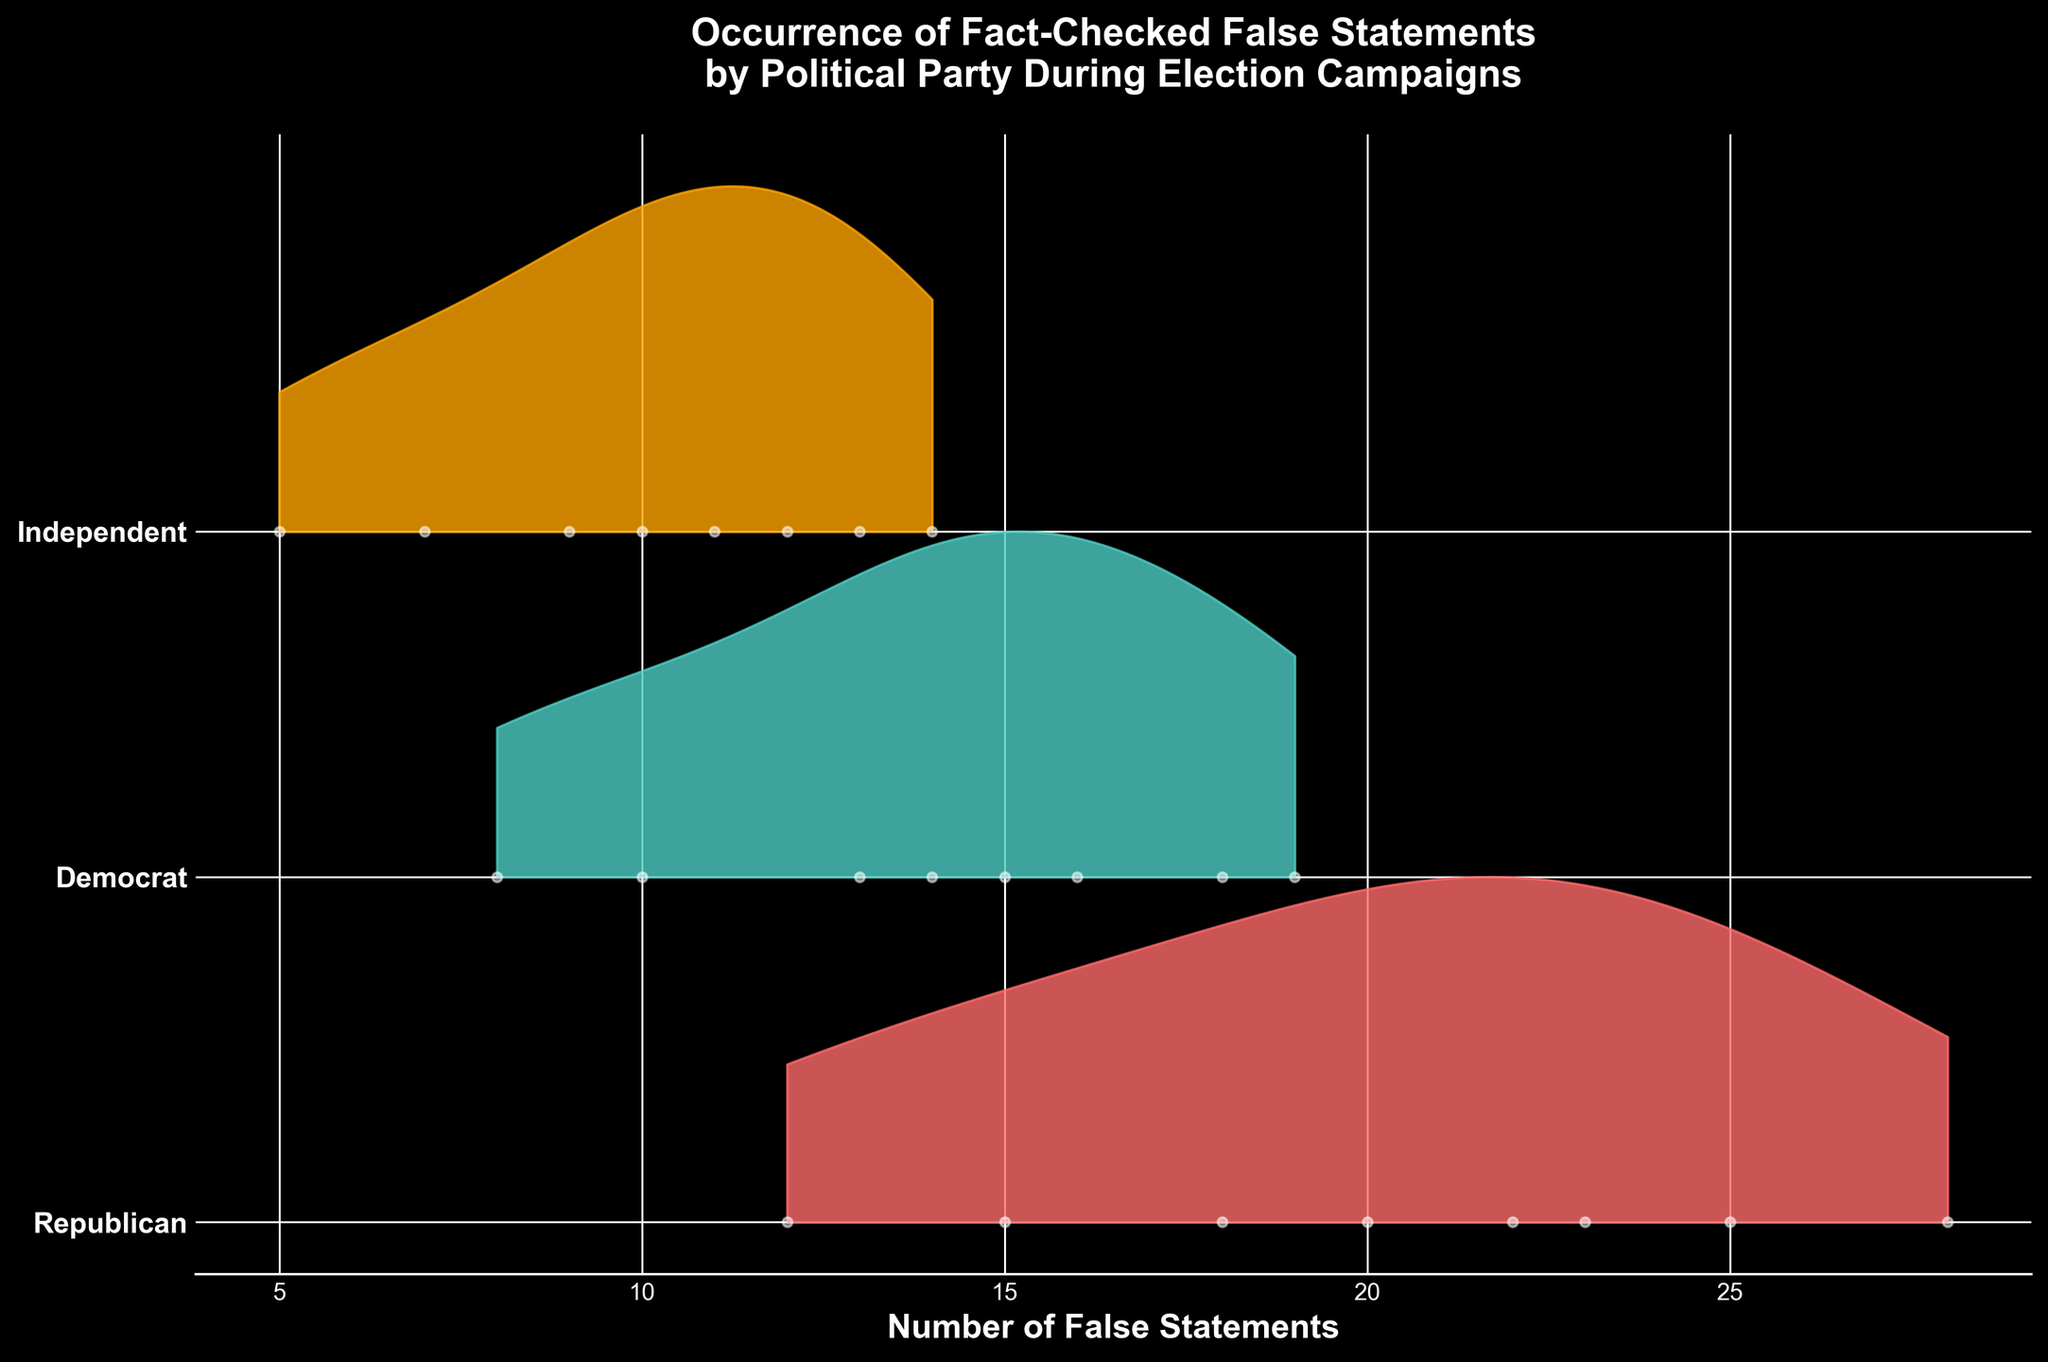What's the title of the figure? The title is positioned at the top of the figure, and it should be clearly visible. It provides a description of what the figure is about.
Answer: Occurrence of Fact-Checked False Statements by Political Party During Election Campaigns What does the x-axis represent? The x-axis label is typically found at the bottom, and it indicates what the horizontal axis measures.
Answer: Number of False Statements Which political party has the highest peak in the number of false statements? By looking at the peaks of the ridgelines for each political party, we can determine which party reached the highest number of false statements. The peak of each ridgeline shows the highest kernel density estimate.
Answer: Republican What color is used to represent the Independent party? The color of each ridgeline indicates different political parties. By identifying the color of the ridgeline corresponding to the Independent party, we can answer this question.
Answer: Orange What is the range of false statements for the Democrat party? The range of false statements can be determined by looking at the spread of the Democrats' ridgeline, which displays the minimum and maximum values reached by this party.
Answer: 8 to 19 What's the average maximum number of false statements made by the three parties? To find this, identify the maximum number of false statements for each of the three parties, sum these maximum values, and then divide by the number of parties (3). Republican: 28, Democrat: 19, Independent: 14. (28 + 19 + 14) / 3
Answer: 20.33 Which party shows the most variability in the number of false statements? Variability can be judged by looking at the width and spread of each ridgeline. The party with the broadest ridgeline and the most spread out points shows the most variability.
Answer: Republican During Week 5, how do the false statements made by Republicans compare to those made by Democrats and Independents? Locate the points for Week 5 on the plot and compare the positions of false statements for each party. Republicans have 25 false statements, Democrats 18, and Independents 13.
Answer: Republicans > Democrats > Independents Which weeks show a consistent increase in false statements for all parties? To identify weeks with an increasing trend for all parties, examine the plot for sequential points where the false statements for all three parties increase from one week to the next. Weeks 1 to 5 show a consistent increase for all.
Answer: Weeks 1 to 5 